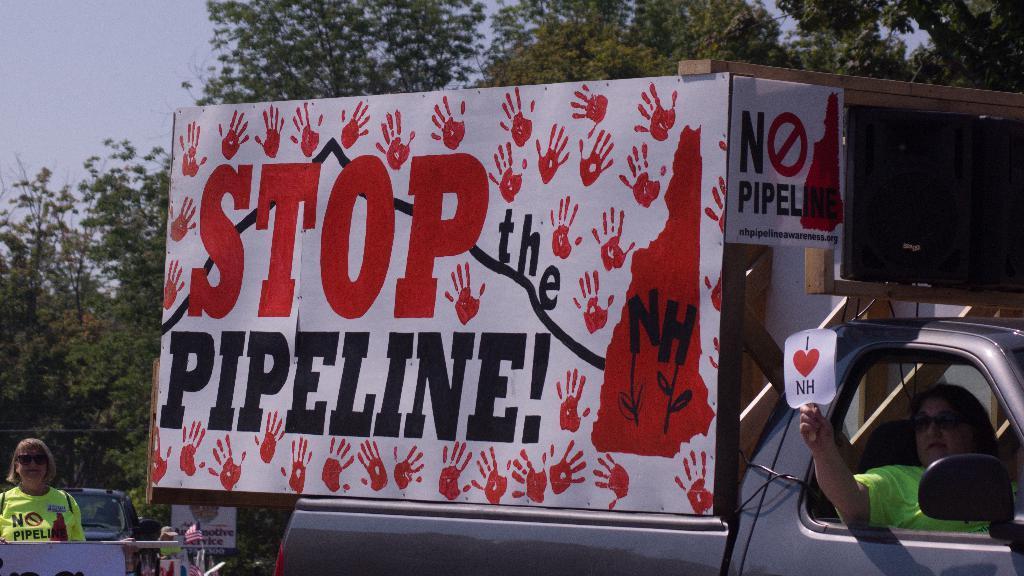How would you summarize this image in a sentence or two? In the foreground of the picture there are vehicles, people, placards and boards. In the background there are trees. 